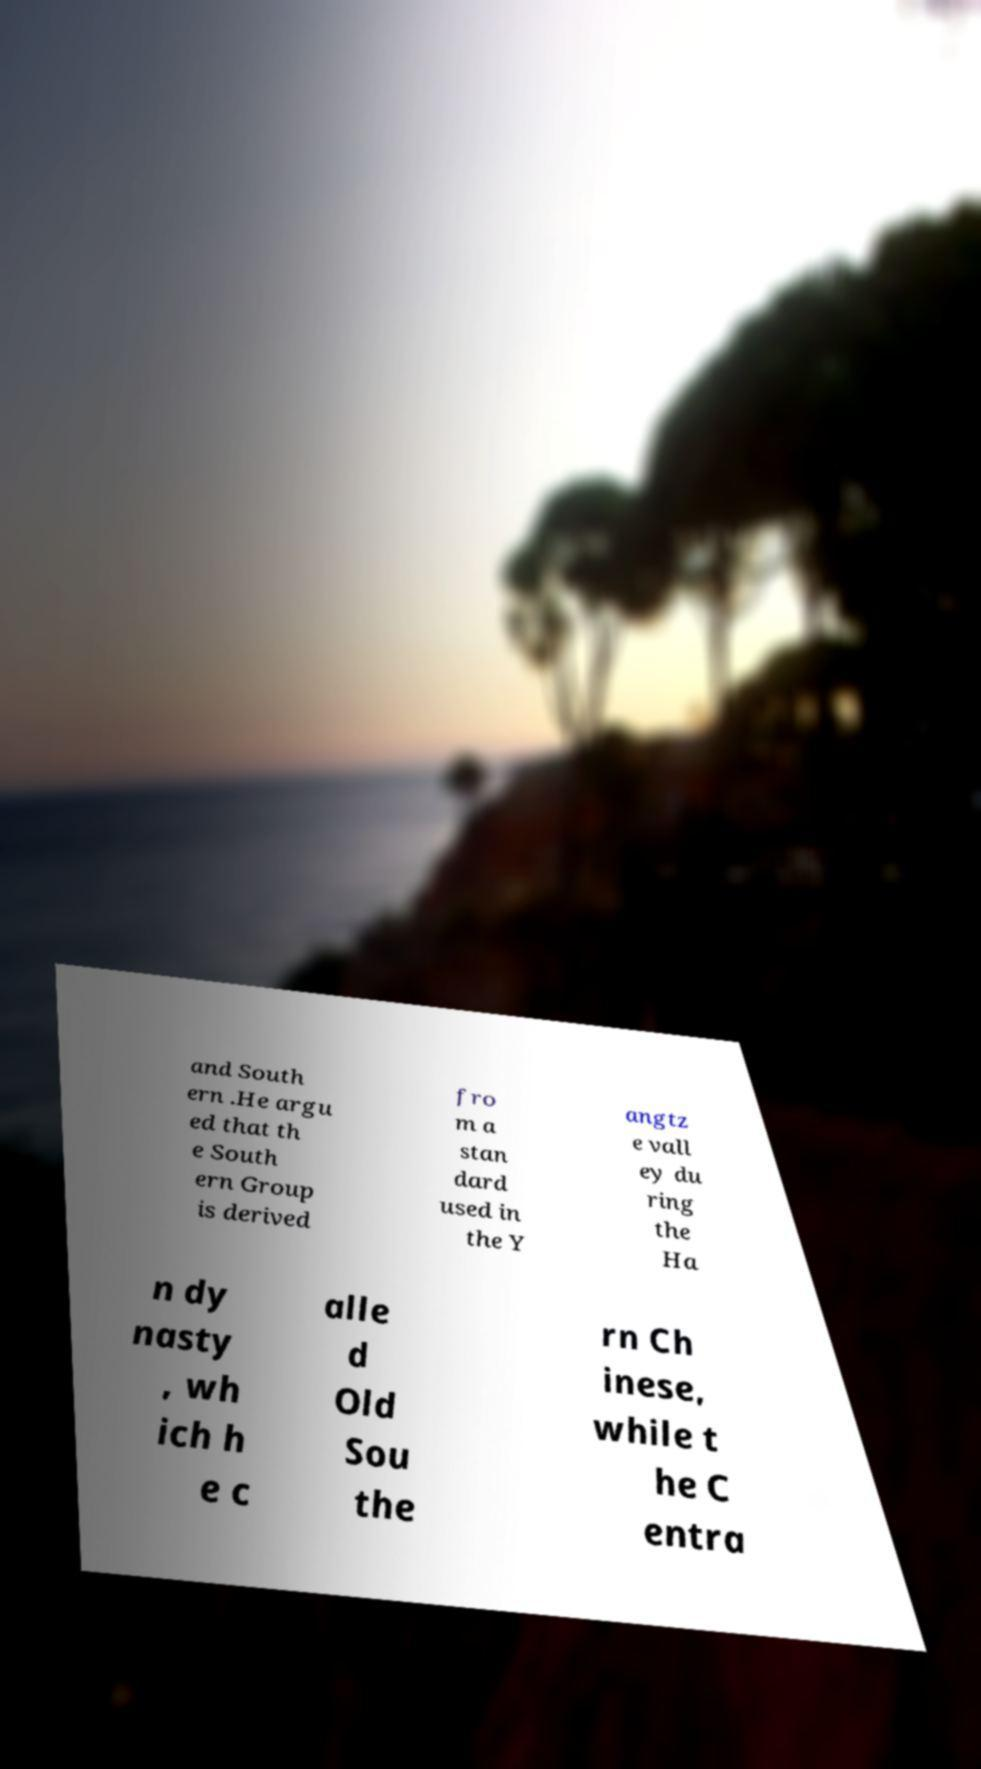Could you extract and type out the text from this image? and South ern .He argu ed that th e South ern Group is derived fro m a stan dard used in the Y angtz e vall ey du ring the Ha n dy nasty , wh ich h e c alle d Old Sou the rn Ch inese, while t he C entra 